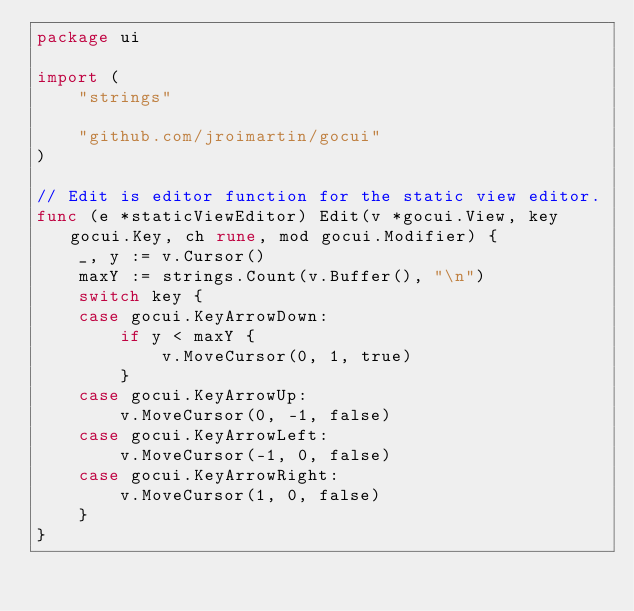<code> <loc_0><loc_0><loc_500><loc_500><_Go_>package ui

import (
	"strings"

	"github.com/jroimartin/gocui"
)

// Edit is editor function for the static view editor.
func (e *staticViewEditor) Edit(v *gocui.View, key gocui.Key, ch rune, mod gocui.Modifier) {
	_, y := v.Cursor()
	maxY := strings.Count(v.Buffer(), "\n")
	switch key {
	case gocui.KeyArrowDown:
		if y < maxY {
			v.MoveCursor(0, 1, true)
		}
	case gocui.KeyArrowUp:
		v.MoveCursor(0, -1, false)
	case gocui.KeyArrowLeft:
		v.MoveCursor(-1, 0, false)
	case gocui.KeyArrowRight:
		v.MoveCursor(1, 0, false)
	}
}
</code> 